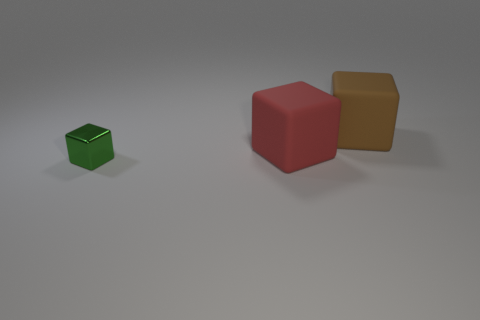How many objects are in front of the large brown matte block and right of the small green metal cube? There is one object located in the specified area, which is a red cube sitting in front of the large brown matte block and to the right of the small green metal cube. 